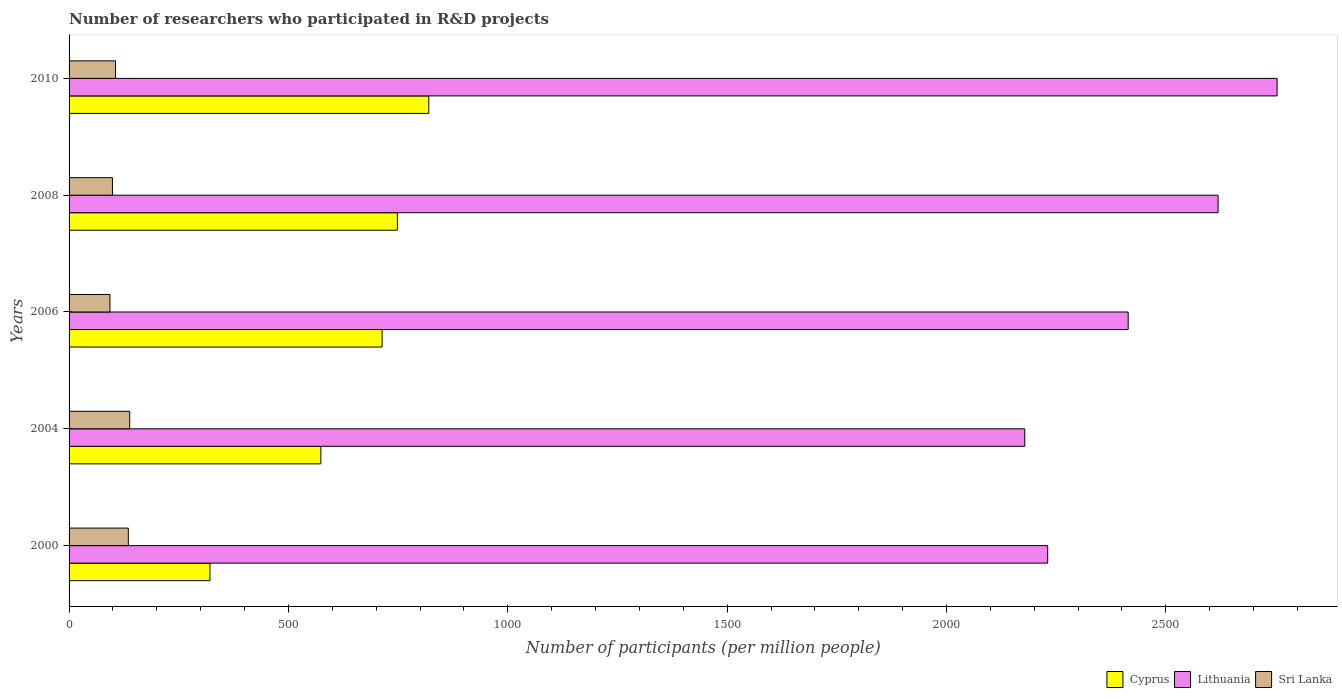Are the number of bars on each tick of the Y-axis equal?
Your response must be concise. Yes. How many bars are there on the 1st tick from the bottom?
Offer a very short reply. 3. What is the label of the 5th group of bars from the top?
Ensure brevity in your answer.  2000. In how many cases, is the number of bars for a given year not equal to the number of legend labels?
Your answer should be very brief. 0. What is the number of researchers who participated in R&D projects in Lithuania in 2004?
Ensure brevity in your answer.  2178.42. Across all years, what is the maximum number of researchers who participated in R&D projects in Sri Lanka?
Your answer should be compact. 138.28. Across all years, what is the minimum number of researchers who participated in R&D projects in Cyprus?
Give a very brief answer. 321.22. In which year was the number of researchers who participated in R&D projects in Cyprus minimum?
Your answer should be compact. 2000. What is the total number of researchers who participated in R&D projects in Cyprus in the graph?
Make the answer very short. 3177.02. What is the difference between the number of researchers who participated in R&D projects in Lithuania in 2008 and that in 2010?
Provide a short and direct response. -134.48. What is the difference between the number of researchers who participated in R&D projects in Sri Lanka in 2006 and the number of researchers who participated in R&D projects in Lithuania in 2000?
Keep it short and to the point. -2137.51. What is the average number of researchers who participated in R&D projects in Sri Lanka per year?
Offer a terse response. 114.26. In the year 2010, what is the difference between the number of researchers who participated in R&D projects in Lithuania and number of researchers who participated in R&D projects in Sri Lanka?
Ensure brevity in your answer.  2647.65. What is the ratio of the number of researchers who participated in R&D projects in Lithuania in 2008 to that in 2010?
Your answer should be compact. 0.95. Is the number of researchers who participated in R&D projects in Sri Lanka in 2006 less than that in 2008?
Your answer should be very brief. Yes. What is the difference between the highest and the second highest number of researchers who participated in R&D projects in Cyprus?
Provide a succinct answer. 71.61. What is the difference between the highest and the lowest number of researchers who participated in R&D projects in Cyprus?
Make the answer very short. 498.76. What does the 3rd bar from the top in 2000 represents?
Your answer should be very brief. Cyprus. What does the 1st bar from the bottom in 2000 represents?
Offer a terse response. Cyprus. Is it the case that in every year, the sum of the number of researchers who participated in R&D projects in Lithuania and number of researchers who participated in R&D projects in Sri Lanka is greater than the number of researchers who participated in R&D projects in Cyprus?
Provide a short and direct response. Yes. What is the difference between two consecutive major ticks on the X-axis?
Keep it short and to the point. 500. Does the graph contain any zero values?
Make the answer very short. No. Does the graph contain grids?
Ensure brevity in your answer.  No. Where does the legend appear in the graph?
Offer a terse response. Bottom right. How many legend labels are there?
Give a very brief answer. 3. What is the title of the graph?
Provide a short and direct response. Number of researchers who participated in R&D projects. What is the label or title of the X-axis?
Your answer should be compact. Number of participants (per million people). What is the Number of participants (per million people) in Cyprus in 2000?
Your answer should be very brief. 321.22. What is the Number of participants (per million people) of Lithuania in 2000?
Offer a terse response. 2230.69. What is the Number of participants (per million people) in Sri Lanka in 2000?
Ensure brevity in your answer.  135.06. What is the Number of participants (per million people) in Cyprus in 2004?
Your answer should be very brief. 573.92. What is the Number of participants (per million people) in Lithuania in 2004?
Offer a very short reply. 2178.42. What is the Number of participants (per million people) in Sri Lanka in 2004?
Offer a terse response. 138.28. What is the Number of participants (per million people) of Cyprus in 2006?
Keep it short and to the point. 713.54. What is the Number of participants (per million people) of Lithuania in 2006?
Provide a succinct answer. 2414.14. What is the Number of participants (per million people) of Sri Lanka in 2006?
Keep it short and to the point. 93.18. What is the Number of participants (per million people) in Cyprus in 2008?
Keep it short and to the point. 748.37. What is the Number of participants (per million people) of Lithuania in 2008?
Provide a succinct answer. 2619.11. What is the Number of participants (per million people) in Sri Lanka in 2008?
Your response must be concise. 98.85. What is the Number of participants (per million people) of Cyprus in 2010?
Give a very brief answer. 819.98. What is the Number of participants (per million people) of Lithuania in 2010?
Offer a terse response. 2753.59. What is the Number of participants (per million people) of Sri Lanka in 2010?
Keep it short and to the point. 105.93. Across all years, what is the maximum Number of participants (per million people) in Cyprus?
Provide a succinct answer. 819.98. Across all years, what is the maximum Number of participants (per million people) of Lithuania?
Offer a terse response. 2753.59. Across all years, what is the maximum Number of participants (per million people) in Sri Lanka?
Make the answer very short. 138.28. Across all years, what is the minimum Number of participants (per million people) of Cyprus?
Your response must be concise. 321.22. Across all years, what is the minimum Number of participants (per million people) in Lithuania?
Your response must be concise. 2178.42. Across all years, what is the minimum Number of participants (per million people) of Sri Lanka?
Your answer should be very brief. 93.18. What is the total Number of participants (per million people) in Cyprus in the graph?
Your response must be concise. 3177.02. What is the total Number of participants (per million people) of Lithuania in the graph?
Make the answer very short. 1.22e+04. What is the total Number of participants (per million people) in Sri Lanka in the graph?
Give a very brief answer. 571.3. What is the difference between the Number of participants (per million people) of Cyprus in 2000 and that in 2004?
Your response must be concise. -252.7. What is the difference between the Number of participants (per million people) in Lithuania in 2000 and that in 2004?
Keep it short and to the point. 52.27. What is the difference between the Number of participants (per million people) in Sri Lanka in 2000 and that in 2004?
Your response must be concise. -3.21. What is the difference between the Number of participants (per million people) in Cyprus in 2000 and that in 2006?
Give a very brief answer. -392.32. What is the difference between the Number of participants (per million people) of Lithuania in 2000 and that in 2006?
Provide a short and direct response. -183.45. What is the difference between the Number of participants (per million people) of Sri Lanka in 2000 and that in 2006?
Provide a succinct answer. 41.89. What is the difference between the Number of participants (per million people) of Cyprus in 2000 and that in 2008?
Offer a terse response. -427.15. What is the difference between the Number of participants (per million people) of Lithuania in 2000 and that in 2008?
Make the answer very short. -388.42. What is the difference between the Number of participants (per million people) of Sri Lanka in 2000 and that in 2008?
Your response must be concise. 36.21. What is the difference between the Number of participants (per million people) in Cyprus in 2000 and that in 2010?
Offer a very short reply. -498.76. What is the difference between the Number of participants (per million people) in Lithuania in 2000 and that in 2010?
Your answer should be very brief. -522.9. What is the difference between the Number of participants (per million people) of Sri Lanka in 2000 and that in 2010?
Ensure brevity in your answer.  29.13. What is the difference between the Number of participants (per million people) of Cyprus in 2004 and that in 2006?
Keep it short and to the point. -139.62. What is the difference between the Number of participants (per million people) of Lithuania in 2004 and that in 2006?
Give a very brief answer. -235.72. What is the difference between the Number of participants (per million people) in Sri Lanka in 2004 and that in 2006?
Your answer should be compact. 45.1. What is the difference between the Number of participants (per million people) in Cyprus in 2004 and that in 2008?
Make the answer very short. -174.45. What is the difference between the Number of participants (per million people) of Lithuania in 2004 and that in 2008?
Your response must be concise. -440.69. What is the difference between the Number of participants (per million people) in Sri Lanka in 2004 and that in 2008?
Your answer should be compact. 39.43. What is the difference between the Number of participants (per million people) in Cyprus in 2004 and that in 2010?
Your response must be concise. -246.06. What is the difference between the Number of participants (per million people) in Lithuania in 2004 and that in 2010?
Your answer should be very brief. -575.17. What is the difference between the Number of participants (per million people) in Sri Lanka in 2004 and that in 2010?
Offer a terse response. 32.34. What is the difference between the Number of participants (per million people) in Cyprus in 2006 and that in 2008?
Make the answer very short. -34.83. What is the difference between the Number of participants (per million people) of Lithuania in 2006 and that in 2008?
Offer a very short reply. -204.97. What is the difference between the Number of participants (per million people) of Sri Lanka in 2006 and that in 2008?
Offer a very short reply. -5.67. What is the difference between the Number of participants (per million people) of Cyprus in 2006 and that in 2010?
Provide a short and direct response. -106.44. What is the difference between the Number of participants (per million people) of Lithuania in 2006 and that in 2010?
Keep it short and to the point. -339.45. What is the difference between the Number of participants (per million people) in Sri Lanka in 2006 and that in 2010?
Your answer should be compact. -12.76. What is the difference between the Number of participants (per million people) in Cyprus in 2008 and that in 2010?
Your answer should be compact. -71.61. What is the difference between the Number of participants (per million people) of Lithuania in 2008 and that in 2010?
Give a very brief answer. -134.48. What is the difference between the Number of participants (per million people) in Sri Lanka in 2008 and that in 2010?
Give a very brief answer. -7.08. What is the difference between the Number of participants (per million people) of Cyprus in 2000 and the Number of participants (per million people) of Lithuania in 2004?
Your response must be concise. -1857.2. What is the difference between the Number of participants (per million people) of Cyprus in 2000 and the Number of participants (per million people) of Sri Lanka in 2004?
Ensure brevity in your answer.  182.94. What is the difference between the Number of participants (per million people) in Lithuania in 2000 and the Number of participants (per million people) in Sri Lanka in 2004?
Give a very brief answer. 2092.41. What is the difference between the Number of participants (per million people) in Cyprus in 2000 and the Number of participants (per million people) in Lithuania in 2006?
Your answer should be very brief. -2092.92. What is the difference between the Number of participants (per million people) of Cyprus in 2000 and the Number of participants (per million people) of Sri Lanka in 2006?
Your answer should be very brief. 228.04. What is the difference between the Number of participants (per million people) in Lithuania in 2000 and the Number of participants (per million people) in Sri Lanka in 2006?
Your answer should be very brief. 2137.51. What is the difference between the Number of participants (per million people) of Cyprus in 2000 and the Number of participants (per million people) of Lithuania in 2008?
Provide a short and direct response. -2297.89. What is the difference between the Number of participants (per million people) of Cyprus in 2000 and the Number of participants (per million people) of Sri Lanka in 2008?
Give a very brief answer. 222.37. What is the difference between the Number of participants (per million people) in Lithuania in 2000 and the Number of participants (per million people) in Sri Lanka in 2008?
Your answer should be very brief. 2131.84. What is the difference between the Number of participants (per million people) of Cyprus in 2000 and the Number of participants (per million people) of Lithuania in 2010?
Keep it short and to the point. -2432.37. What is the difference between the Number of participants (per million people) of Cyprus in 2000 and the Number of participants (per million people) of Sri Lanka in 2010?
Keep it short and to the point. 215.28. What is the difference between the Number of participants (per million people) of Lithuania in 2000 and the Number of participants (per million people) of Sri Lanka in 2010?
Your response must be concise. 2124.75. What is the difference between the Number of participants (per million people) of Cyprus in 2004 and the Number of participants (per million people) of Lithuania in 2006?
Keep it short and to the point. -1840.22. What is the difference between the Number of participants (per million people) in Cyprus in 2004 and the Number of participants (per million people) in Sri Lanka in 2006?
Provide a short and direct response. 480.74. What is the difference between the Number of participants (per million people) of Lithuania in 2004 and the Number of participants (per million people) of Sri Lanka in 2006?
Give a very brief answer. 2085.24. What is the difference between the Number of participants (per million people) of Cyprus in 2004 and the Number of participants (per million people) of Lithuania in 2008?
Provide a succinct answer. -2045.19. What is the difference between the Number of participants (per million people) in Cyprus in 2004 and the Number of participants (per million people) in Sri Lanka in 2008?
Your response must be concise. 475.07. What is the difference between the Number of participants (per million people) of Lithuania in 2004 and the Number of participants (per million people) of Sri Lanka in 2008?
Keep it short and to the point. 2079.57. What is the difference between the Number of participants (per million people) of Cyprus in 2004 and the Number of participants (per million people) of Lithuania in 2010?
Your answer should be compact. -2179.67. What is the difference between the Number of participants (per million people) in Cyprus in 2004 and the Number of participants (per million people) in Sri Lanka in 2010?
Ensure brevity in your answer.  467.98. What is the difference between the Number of participants (per million people) in Lithuania in 2004 and the Number of participants (per million people) in Sri Lanka in 2010?
Offer a very short reply. 2072.49. What is the difference between the Number of participants (per million people) of Cyprus in 2006 and the Number of participants (per million people) of Lithuania in 2008?
Make the answer very short. -1905.56. What is the difference between the Number of participants (per million people) of Cyprus in 2006 and the Number of participants (per million people) of Sri Lanka in 2008?
Make the answer very short. 614.69. What is the difference between the Number of participants (per million people) of Lithuania in 2006 and the Number of participants (per million people) of Sri Lanka in 2008?
Keep it short and to the point. 2315.29. What is the difference between the Number of participants (per million people) in Cyprus in 2006 and the Number of participants (per million people) in Lithuania in 2010?
Offer a very short reply. -2040.05. What is the difference between the Number of participants (per million people) of Cyprus in 2006 and the Number of participants (per million people) of Sri Lanka in 2010?
Your response must be concise. 607.61. What is the difference between the Number of participants (per million people) in Lithuania in 2006 and the Number of participants (per million people) in Sri Lanka in 2010?
Provide a short and direct response. 2308.2. What is the difference between the Number of participants (per million people) of Cyprus in 2008 and the Number of participants (per million people) of Lithuania in 2010?
Your response must be concise. -2005.22. What is the difference between the Number of participants (per million people) in Cyprus in 2008 and the Number of participants (per million people) in Sri Lanka in 2010?
Your answer should be compact. 642.43. What is the difference between the Number of participants (per million people) of Lithuania in 2008 and the Number of participants (per million people) of Sri Lanka in 2010?
Your answer should be very brief. 2513.17. What is the average Number of participants (per million people) in Cyprus per year?
Provide a succinct answer. 635.4. What is the average Number of participants (per million people) of Lithuania per year?
Keep it short and to the point. 2439.19. What is the average Number of participants (per million people) of Sri Lanka per year?
Make the answer very short. 114.26. In the year 2000, what is the difference between the Number of participants (per million people) in Cyprus and Number of participants (per million people) in Lithuania?
Provide a short and direct response. -1909.47. In the year 2000, what is the difference between the Number of participants (per million people) in Cyprus and Number of participants (per million people) in Sri Lanka?
Make the answer very short. 186.15. In the year 2000, what is the difference between the Number of participants (per million people) in Lithuania and Number of participants (per million people) in Sri Lanka?
Your answer should be very brief. 2095.62. In the year 2004, what is the difference between the Number of participants (per million people) of Cyprus and Number of participants (per million people) of Lithuania?
Make the answer very short. -1604.5. In the year 2004, what is the difference between the Number of participants (per million people) in Cyprus and Number of participants (per million people) in Sri Lanka?
Provide a succinct answer. 435.64. In the year 2004, what is the difference between the Number of participants (per million people) of Lithuania and Number of participants (per million people) of Sri Lanka?
Give a very brief answer. 2040.14. In the year 2006, what is the difference between the Number of participants (per million people) of Cyprus and Number of participants (per million people) of Lithuania?
Offer a very short reply. -1700.6. In the year 2006, what is the difference between the Number of participants (per million people) in Cyprus and Number of participants (per million people) in Sri Lanka?
Ensure brevity in your answer.  620.36. In the year 2006, what is the difference between the Number of participants (per million people) of Lithuania and Number of participants (per million people) of Sri Lanka?
Offer a very short reply. 2320.96. In the year 2008, what is the difference between the Number of participants (per million people) in Cyprus and Number of participants (per million people) in Lithuania?
Ensure brevity in your answer.  -1870.74. In the year 2008, what is the difference between the Number of participants (per million people) of Cyprus and Number of participants (per million people) of Sri Lanka?
Offer a very short reply. 649.52. In the year 2008, what is the difference between the Number of participants (per million people) of Lithuania and Number of participants (per million people) of Sri Lanka?
Provide a short and direct response. 2520.26. In the year 2010, what is the difference between the Number of participants (per million people) of Cyprus and Number of participants (per million people) of Lithuania?
Your response must be concise. -1933.61. In the year 2010, what is the difference between the Number of participants (per million people) in Cyprus and Number of participants (per million people) in Sri Lanka?
Your answer should be very brief. 714.05. In the year 2010, what is the difference between the Number of participants (per million people) in Lithuania and Number of participants (per million people) in Sri Lanka?
Your response must be concise. 2647.65. What is the ratio of the Number of participants (per million people) in Cyprus in 2000 to that in 2004?
Make the answer very short. 0.56. What is the ratio of the Number of participants (per million people) of Sri Lanka in 2000 to that in 2004?
Offer a terse response. 0.98. What is the ratio of the Number of participants (per million people) in Cyprus in 2000 to that in 2006?
Your answer should be compact. 0.45. What is the ratio of the Number of participants (per million people) in Lithuania in 2000 to that in 2006?
Your answer should be very brief. 0.92. What is the ratio of the Number of participants (per million people) in Sri Lanka in 2000 to that in 2006?
Give a very brief answer. 1.45. What is the ratio of the Number of participants (per million people) of Cyprus in 2000 to that in 2008?
Your response must be concise. 0.43. What is the ratio of the Number of participants (per million people) of Lithuania in 2000 to that in 2008?
Give a very brief answer. 0.85. What is the ratio of the Number of participants (per million people) of Sri Lanka in 2000 to that in 2008?
Make the answer very short. 1.37. What is the ratio of the Number of participants (per million people) of Cyprus in 2000 to that in 2010?
Make the answer very short. 0.39. What is the ratio of the Number of participants (per million people) of Lithuania in 2000 to that in 2010?
Ensure brevity in your answer.  0.81. What is the ratio of the Number of participants (per million people) in Sri Lanka in 2000 to that in 2010?
Give a very brief answer. 1.27. What is the ratio of the Number of participants (per million people) in Cyprus in 2004 to that in 2006?
Offer a very short reply. 0.8. What is the ratio of the Number of participants (per million people) in Lithuania in 2004 to that in 2006?
Ensure brevity in your answer.  0.9. What is the ratio of the Number of participants (per million people) of Sri Lanka in 2004 to that in 2006?
Your answer should be very brief. 1.48. What is the ratio of the Number of participants (per million people) of Cyprus in 2004 to that in 2008?
Your answer should be very brief. 0.77. What is the ratio of the Number of participants (per million people) in Lithuania in 2004 to that in 2008?
Ensure brevity in your answer.  0.83. What is the ratio of the Number of participants (per million people) in Sri Lanka in 2004 to that in 2008?
Provide a short and direct response. 1.4. What is the ratio of the Number of participants (per million people) of Cyprus in 2004 to that in 2010?
Provide a succinct answer. 0.7. What is the ratio of the Number of participants (per million people) of Lithuania in 2004 to that in 2010?
Offer a terse response. 0.79. What is the ratio of the Number of participants (per million people) in Sri Lanka in 2004 to that in 2010?
Your response must be concise. 1.31. What is the ratio of the Number of participants (per million people) of Cyprus in 2006 to that in 2008?
Keep it short and to the point. 0.95. What is the ratio of the Number of participants (per million people) in Lithuania in 2006 to that in 2008?
Ensure brevity in your answer.  0.92. What is the ratio of the Number of participants (per million people) in Sri Lanka in 2006 to that in 2008?
Offer a very short reply. 0.94. What is the ratio of the Number of participants (per million people) of Cyprus in 2006 to that in 2010?
Offer a very short reply. 0.87. What is the ratio of the Number of participants (per million people) of Lithuania in 2006 to that in 2010?
Offer a terse response. 0.88. What is the ratio of the Number of participants (per million people) in Sri Lanka in 2006 to that in 2010?
Provide a short and direct response. 0.88. What is the ratio of the Number of participants (per million people) in Cyprus in 2008 to that in 2010?
Offer a very short reply. 0.91. What is the ratio of the Number of participants (per million people) in Lithuania in 2008 to that in 2010?
Your answer should be very brief. 0.95. What is the ratio of the Number of participants (per million people) of Sri Lanka in 2008 to that in 2010?
Provide a short and direct response. 0.93. What is the difference between the highest and the second highest Number of participants (per million people) in Cyprus?
Offer a terse response. 71.61. What is the difference between the highest and the second highest Number of participants (per million people) of Lithuania?
Offer a very short reply. 134.48. What is the difference between the highest and the second highest Number of participants (per million people) of Sri Lanka?
Your answer should be very brief. 3.21. What is the difference between the highest and the lowest Number of participants (per million people) of Cyprus?
Offer a very short reply. 498.76. What is the difference between the highest and the lowest Number of participants (per million people) of Lithuania?
Offer a terse response. 575.17. What is the difference between the highest and the lowest Number of participants (per million people) of Sri Lanka?
Keep it short and to the point. 45.1. 